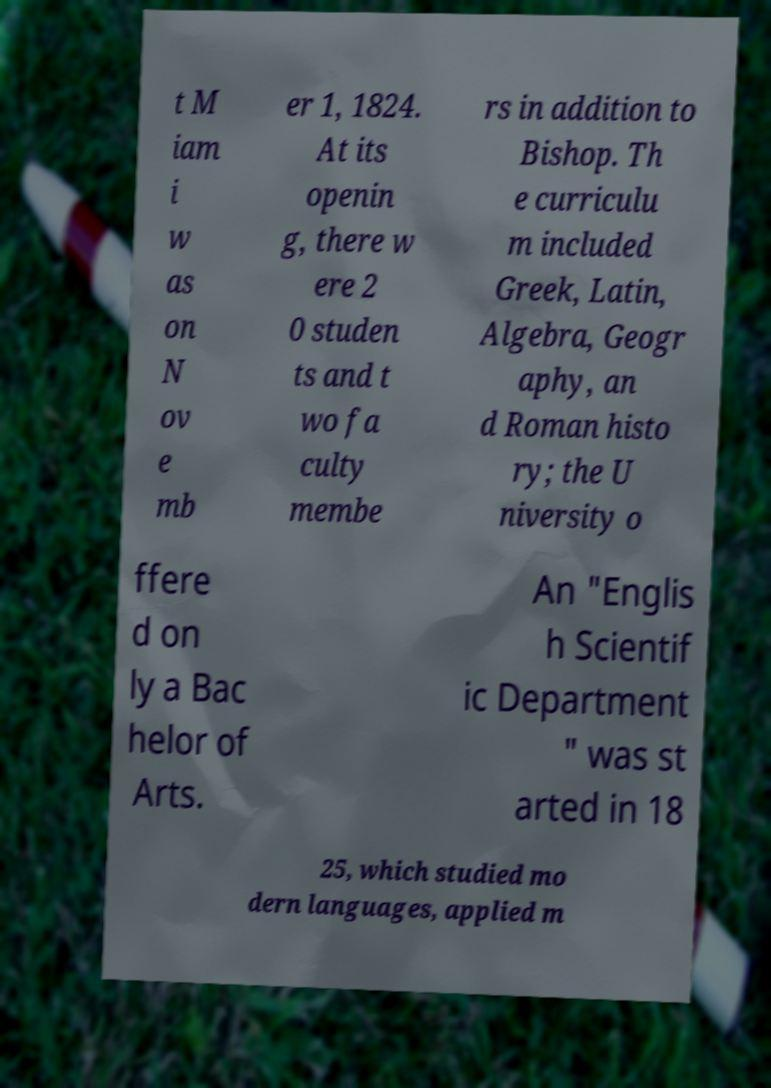Please read and relay the text visible in this image. What does it say? t M iam i w as on N ov e mb er 1, 1824. At its openin g, there w ere 2 0 studen ts and t wo fa culty membe rs in addition to Bishop. Th e curriculu m included Greek, Latin, Algebra, Geogr aphy, an d Roman histo ry; the U niversity o ffere d on ly a Bac helor of Arts. An "Englis h Scientif ic Department " was st arted in 18 25, which studied mo dern languages, applied m 